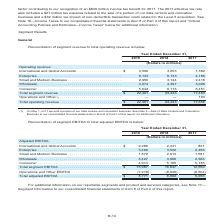According to Centurylink's financial document, What additional information does Note 17 provide? additional information on our reportable segments and product and services categories. The document states: "For additional information on our reportable segments and product and services categories, see Note 17— Segment Information to our consolidated financ..." Also, What is the total adjusted EBITDA in 2019? According to the financial document, $8,771 (in millions). The relevant text states: "Total adjusted EBITDA . $ 8,771 8,602 6,056..." Also, What are the segments under Adjusted EBITDA? The document contains multiple relevant values: International and Global Accounts, Enterprise, Small and Medium Business, Wholesale, Consumer. From the document: "rnational and Global Accounts . $ 2,286 2,341 821 Enterprise . 3,490 3,522 2,456 Small and Medium Business . 1,870 2,013 1,581 Wholesale . 3,427 3,666..." Also, How many segments are there under Adjusted EBITDA? Counting the relevant items in the document: International and Global Accounts, Enterprise, Small and Medium Business, Wholesale, Consumer, I find 5 instances. The key data points involved are: Consumer, Enterprise, International and Global Accounts. Also, can you calculate: What is the change in the adjusted EBITDA under Wholesale in 2019 from 2018? Based on the calculation: 3,427-3,666, the result is -239 (in millions). This is based on the information: "um Business . 1,870 2,013 1,581 Wholesale . 3,427 3,666 2,566 Consumer . 4,914 5,105 5,136 d Medium Business . 1,870 2,013 1,581 Wholesale . 3,427 3,666 2,566 Consumer . 4,914 5,105 5,136..." The key data points involved are: 3,427, 3,666. Also, can you calculate: What is the average total adjusted EBITDA over the three years? To answer this question, I need to perform calculations using the financial data. The calculation is: (8,771+8,602+6,056)/3, which equals 7809.67 (in millions). This is based on the information: "Total adjusted EBITDA . $ 8,771 8,602 6,056 Total adjusted EBITDA . $ 8,771 8,602 6,056 Total adjusted EBITDA . $ 8,771 8,602 6,056..." The key data points involved are: 6,056, 8,602, 8,771. 